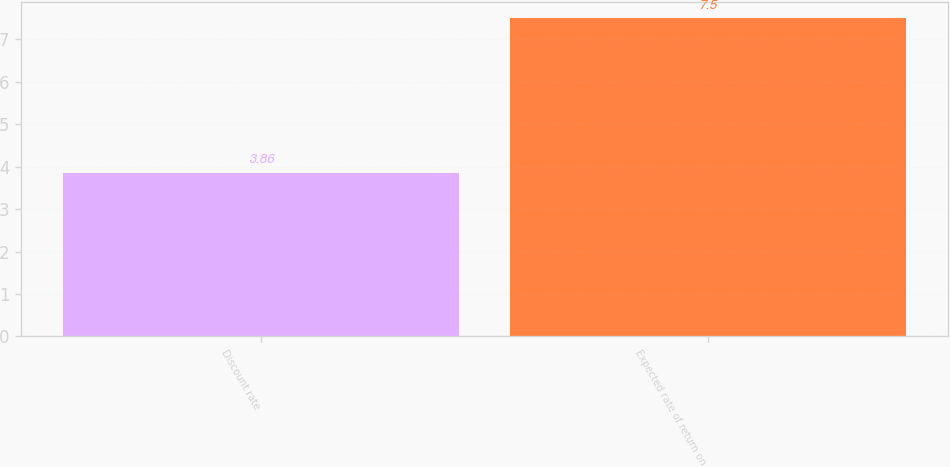<chart> <loc_0><loc_0><loc_500><loc_500><bar_chart><fcel>Discount rate<fcel>Expected rate of return on<nl><fcel>3.86<fcel>7.5<nl></chart> 